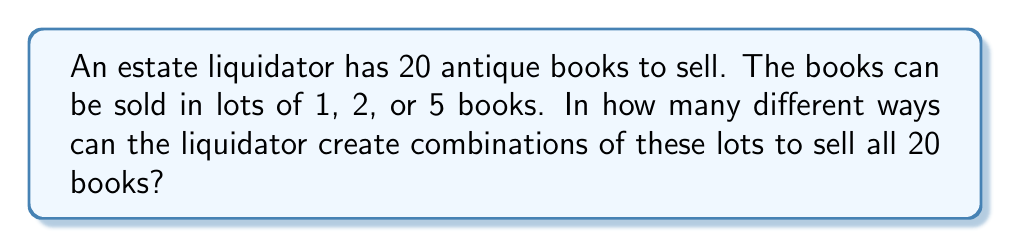Help me with this question. Let's approach this step-by-step using the concept of integer partitions with restricted parts.

1) Let $x$, $y$, and $z$ represent the number of lots of 1, 2, and 5 books respectively.

2) We need to solve the equation:

   $$x + 2y + 5z = 20$$

   where $x$, $y$, and $z$ are non-negative integers.

3) We can use the generating function method. The generating function for this problem is:

   $$G(t) = (1 + t + t^2 + ...)(1 + t^2 + t^4 + ...)(1 + t^5 + t^{10} + t^{15} + ...)$$

4) This can be simplified to:

   $$G(t) = \frac{1}{1-t} \cdot \frac{1}{1-t^2} \cdot \frac{1}{1-t^5}$$

5) We need to find the coefficient of $t^{20}$ in this generating function.

6) Expanding this manually would be tedious, so we can use the stars and bars method to count the solutions.

7) We can think of this as distributing 20 identical objects (books) into 3 distinct boxes (lot sizes), where each box can hold any number of objects.

8) The number of ways to do this is given by the combination:

   $$\binom{20 + 3 - 1}{3 - 1} = \binom{22}{2}$$

9) We can calculate this as:

   $$\binom{22}{2} = \frac{22!}{2!(22-2)!} = \frac{22 \cdot 21}{2} = 231$$

Therefore, there are 231 different ways to create combinations of lots to sell all 20 books.
Answer: 231 